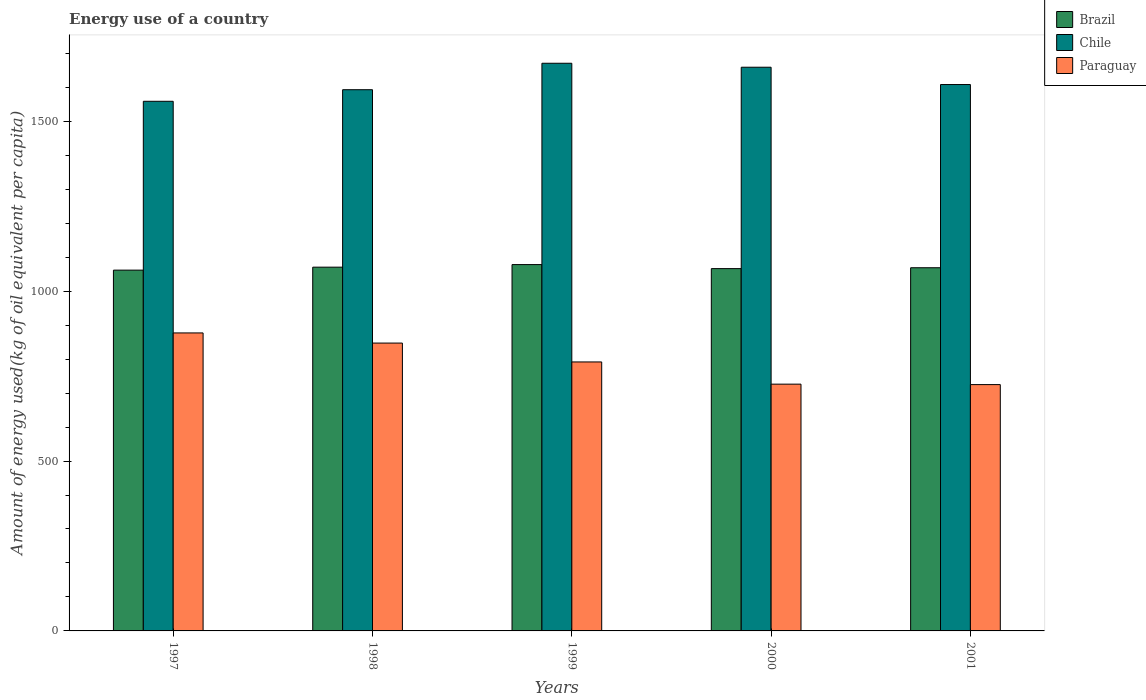How many different coloured bars are there?
Make the answer very short. 3. Are the number of bars per tick equal to the number of legend labels?
Keep it short and to the point. Yes. How many bars are there on the 1st tick from the left?
Make the answer very short. 3. How many bars are there on the 4th tick from the right?
Ensure brevity in your answer.  3. What is the label of the 5th group of bars from the left?
Make the answer very short. 2001. What is the amount of energy used in in Chile in 1999?
Keep it short and to the point. 1670.7. Across all years, what is the maximum amount of energy used in in Brazil?
Ensure brevity in your answer.  1078.18. Across all years, what is the minimum amount of energy used in in Paraguay?
Your answer should be very brief. 724.96. In which year was the amount of energy used in in Paraguay minimum?
Ensure brevity in your answer.  2001. What is the total amount of energy used in in Paraguay in the graph?
Make the answer very short. 3967.11. What is the difference between the amount of energy used in in Brazil in 1998 and that in 2001?
Your answer should be compact. 1.69. What is the difference between the amount of energy used in in Paraguay in 2000 and the amount of energy used in in Chile in 1998?
Keep it short and to the point. -866.56. What is the average amount of energy used in in Paraguay per year?
Ensure brevity in your answer.  793.42. In the year 2001, what is the difference between the amount of energy used in in Paraguay and amount of energy used in in Brazil?
Provide a succinct answer. -343.93. In how many years, is the amount of energy used in in Brazil greater than 1200 kg?
Provide a succinct answer. 0. What is the ratio of the amount of energy used in in Brazil in 1997 to that in 2001?
Give a very brief answer. 0.99. Is the difference between the amount of energy used in in Paraguay in 1998 and 1999 greater than the difference between the amount of energy used in in Brazil in 1998 and 1999?
Give a very brief answer. Yes. What is the difference between the highest and the second highest amount of energy used in in Brazil?
Your answer should be compact. 7.59. What is the difference between the highest and the lowest amount of energy used in in Brazil?
Offer a very short reply. 16.35. What does the 3rd bar from the left in 1998 represents?
Provide a short and direct response. Paraguay. How many bars are there?
Ensure brevity in your answer.  15. Are the values on the major ticks of Y-axis written in scientific E-notation?
Provide a short and direct response. No. Does the graph contain any zero values?
Offer a very short reply. No. Does the graph contain grids?
Make the answer very short. No. Where does the legend appear in the graph?
Give a very brief answer. Top right. What is the title of the graph?
Provide a succinct answer. Energy use of a country. What is the label or title of the X-axis?
Ensure brevity in your answer.  Years. What is the label or title of the Y-axis?
Your response must be concise. Amount of energy used(kg of oil equivalent per capita). What is the Amount of energy used(kg of oil equivalent per capita) in Brazil in 1997?
Your response must be concise. 1061.84. What is the Amount of energy used(kg of oil equivalent per capita) in Chile in 1997?
Your answer should be very brief. 1558.79. What is the Amount of energy used(kg of oil equivalent per capita) of Paraguay in 1997?
Your response must be concise. 877.04. What is the Amount of energy used(kg of oil equivalent per capita) of Brazil in 1998?
Your response must be concise. 1070.59. What is the Amount of energy used(kg of oil equivalent per capita) in Chile in 1998?
Give a very brief answer. 1592.83. What is the Amount of energy used(kg of oil equivalent per capita) of Paraguay in 1998?
Keep it short and to the point. 847.18. What is the Amount of energy used(kg of oil equivalent per capita) of Brazil in 1999?
Make the answer very short. 1078.18. What is the Amount of energy used(kg of oil equivalent per capita) in Chile in 1999?
Offer a terse response. 1670.7. What is the Amount of energy used(kg of oil equivalent per capita) in Paraguay in 1999?
Your answer should be very brief. 791.65. What is the Amount of energy used(kg of oil equivalent per capita) of Brazil in 2000?
Keep it short and to the point. 1066.3. What is the Amount of energy used(kg of oil equivalent per capita) in Chile in 2000?
Provide a succinct answer. 1659.01. What is the Amount of energy used(kg of oil equivalent per capita) of Paraguay in 2000?
Your answer should be compact. 726.27. What is the Amount of energy used(kg of oil equivalent per capita) in Brazil in 2001?
Keep it short and to the point. 1068.9. What is the Amount of energy used(kg of oil equivalent per capita) of Chile in 2001?
Give a very brief answer. 1608.07. What is the Amount of energy used(kg of oil equivalent per capita) in Paraguay in 2001?
Your answer should be compact. 724.96. Across all years, what is the maximum Amount of energy used(kg of oil equivalent per capita) of Brazil?
Keep it short and to the point. 1078.18. Across all years, what is the maximum Amount of energy used(kg of oil equivalent per capita) in Chile?
Ensure brevity in your answer.  1670.7. Across all years, what is the maximum Amount of energy used(kg of oil equivalent per capita) of Paraguay?
Offer a very short reply. 877.04. Across all years, what is the minimum Amount of energy used(kg of oil equivalent per capita) of Brazil?
Offer a terse response. 1061.84. Across all years, what is the minimum Amount of energy used(kg of oil equivalent per capita) of Chile?
Ensure brevity in your answer.  1558.79. Across all years, what is the minimum Amount of energy used(kg of oil equivalent per capita) in Paraguay?
Give a very brief answer. 724.96. What is the total Amount of energy used(kg of oil equivalent per capita) of Brazil in the graph?
Provide a short and direct response. 5345.81. What is the total Amount of energy used(kg of oil equivalent per capita) of Chile in the graph?
Make the answer very short. 8089.39. What is the total Amount of energy used(kg of oil equivalent per capita) in Paraguay in the graph?
Offer a terse response. 3967.11. What is the difference between the Amount of energy used(kg of oil equivalent per capita) in Brazil in 1997 and that in 1998?
Give a very brief answer. -8.75. What is the difference between the Amount of energy used(kg of oil equivalent per capita) of Chile in 1997 and that in 1998?
Provide a succinct answer. -34.05. What is the difference between the Amount of energy used(kg of oil equivalent per capita) of Paraguay in 1997 and that in 1998?
Keep it short and to the point. 29.86. What is the difference between the Amount of energy used(kg of oil equivalent per capita) of Brazil in 1997 and that in 1999?
Offer a terse response. -16.35. What is the difference between the Amount of energy used(kg of oil equivalent per capita) in Chile in 1997 and that in 1999?
Your response must be concise. -111.91. What is the difference between the Amount of energy used(kg of oil equivalent per capita) of Paraguay in 1997 and that in 1999?
Offer a terse response. 85.4. What is the difference between the Amount of energy used(kg of oil equivalent per capita) of Brazil in 1997 and that in 2000?
Offer a terse response. -4.47. What is the difference between the Amount of energy used(kg of oil equivalent per capita) of Chile in 1997 and that in 2000?
Give a very brief answer. -100.22. What is the difference between the Amount of energy used(kg of oil equivalent per capita) of Paraguay in 1997 and that in 2000?
Offer a very short reply. 150.77. What is the difference between the Amount of energy used(kg of oil equivalent per capita) of Brazil in 1997 and that in 2001?
Give a very brief answer. -7.06. What is the difference between the Amount of energy used(kg of oil equivalent per capita) of Chile in 1997 and that in 2001?
Keep it short and to the point. -49.28. What is the difference between the Amount of energy used(kg of oil equivalent per capita) in Paraguay in 1997 and that in 2001?
Ensure brevity in your answer.  152.08. What is the difference between the Amount of energy used(kg of oil equivalent per capita) in Brazil in 1998 and that in 1999?
Keep it short and to the point. -7.59. What is the difference between the Amount of energy used(kg of oil equivalent per capita) of Chile in 1998 and that in 1999?
Your answer should be very brief. -77.87. What is the difference between the Amount of energy used(kg of oil equivalent per capita) in Paraguay in 1998 and that in 1999?
Your answer should be compact. 55.54. What is the difference between the Amount of energy used(kg of oil equivalent per capita) of Brazil in 1998 and that in 2000?
Your answer should be compact. 4.29. What is the difference between the Amount of energy used(kg of oil equivalent per capita) in Chile in 1998 and that in 2000?
Make the answer very short. -66.17. What is the difference between the Amount of energy used(kg of oil equivalent per capita) in Paraguay in 1998 and that in 2000?
Your response must be concise. 120.91. What is the difference between the Amount of energy used(kg of oil equivalent per capita) of Brazil in 1998 and that in 2001?
Your answer should be compact. 1.69. What is the difference between the Amount of energy used(kg of oil equivalent per capita) of Chile in 1998 and that in 2001?
Your answer should be compact. -15.24. What is the difference between the Amount of energy used(kg of oil equivalent per capita) of Paraguay in 1998 and that in 2001?
Provide a short and direct response. 122.22. What is the difference between the Amount of energy used(kg of oil equivalent per capita) in Brazil in 1999 and that in 2000?
Your response must be concise. 11.88. What is the difference between the Amount of energy used(kg of oil equivalent per capita) of Chile in 1999 and that in 2000?
Give a very brief answer. 11.69. What is the difference between the Amount of energy used(kg of oil equivalent per capita) of Paraguay in 1999 and that in 2000?
Give a very brief answer. 65.38. What is the difference between the Amount of energy used(kg of oil equivalent per capita) of Brazil in 1999 and that in 2001?
Give a very brief answer. 9.29. What is the difference between the Amount of energy used(kg of oil equivalent per capita) in Chile in 1999 and that in 2001?
Ensure brevity in your answer.  62.63. What is the difference between the Amount of energy used(kg of oil equivalent per capita) of Paraguay in 1999 and that in 2001?
Offer a terse response. 66.68. What is the difference between the Amount of energy used(kg of oil equivalent per capita) in Brazil in 2000 and that in 2001?
Provide a short and direct response. -2.59. What is the difference between the Amount of energy used(kg of oil equivalent per capita) in Chile in 2000 and that in 2001?
Offer a terse response. 50.94. What is the difference between the Amount of energy used(kg of oil equivalent per capita) in Paraguay in 2000 and that in 2001?
Offer a very short reply. 1.31. What is the difference between the Amount of energy used(kg of oil equivalent per capita) in Brazil in 1997 and the Amount of energy used(kg of oil equivalent per capita) in Chile in 1998?
Provide a succinct answer. -531. What is the difference between the Amount of energy used(kg of oil equivalent per capita) of Brazil in 1997 and the Amount of energy used(kg of oil equivalent per capita) of Paraguay in 1998?
Make the answer very short. 214.65. What is the difference between the Amount of energy used(kg of oil equivalent per capita) of Chile in 1997 and the Amount of energy used(kg of oil equivalent per capita) of Paraguay in 1998?
Offer a terse response. 711.6. What is the difference between the Amount of energy used(kg of oil equivalent per capita) of Brazil in 1997 and the Amount of energy used(kg of oil equivalent per capita) of Chile in 1999?
Your answer should be compact. -608.86. What is the difference between the Amount of energy used(kg of oil equivalent per capita) of Brazil in 1997 and the Amount of energy used(kg of oil equivalent per capita) of Paraguay in 1999?
Provide a short and direct response. 270.19. What is the difference between the Amount of energy used(kg of oil equivalent per capita) of Chile in 1997 and the Amount of energy used(kg of oil equivalent per capita) of Paraguay in 1999?
Keep it short and to the point. 767.14. What is the difference between the Amount of energy used(kg of oil equivalent per capita) in Brazil in 1997 and the Amount of energy used(kg of oil equivalent per capita) in Chile in 2000?
Your answer should be compact. -597.17. What is the difference between the Amount of energy used(kg of oil equivalent per capita) in Brazil in 1997 and the Amount of energy used(kg of oil equivalent per capita) in Paraguay in 2000?
Ensure brevity in your answer.  335.57. What is the difference between the Amount of energy used(kg of oil equivalent per capita) in Chile in 1997 and the Amount of energy used(kg of oil equivalent per capita) in Paraguay in 2000?
Provide a short and direct response. 832.52. What is the difference between the Amount of energy used(kg of oil equivalent per capita) of Brazil in 1997 and the Amount of energy used(kg of oil equivalent per capita) of Chile in 2001?
Keep it short and to the point. -546.23. What is the difference between the Amount of energy used(kg of oil equivalent per capita) of Brazil in 1997 and the Amount of energy used(kg of oil equivalent per capita) of Paraguay in 2001?
Offer a very short reply. 336.87. What is the difference between the Amount of energy used(kg of oil equivalent per capita) of Chile in 1997 and the Amount of energy used(kg of oil equivalent per capita) of Paraguay in 2001?
Give a very brief answer. 833.82. What is the difference between the Amount of energy used(kg of oil equivalent per capita) in Brazil in 1998 and the Amount of energy used(kg of oil equivalent per capita) in Chile in 1999?
Keep it short and to the point. -600.11. What is the difference between the Amount of energy used(kg of oil equivalent per capita) in Brazil in 1998 and the Amount of energy used(kg of oil equivalent per capita) in Paraguay in 1999?
Provide a short and direct response. 278.94. What is the difference between the Amount of energy used(kg of oil equivalent per capita) in Chile in 1998 and the Amount of energy used(kg of oil equivalent per capita) in Paraguay in 1999?
Give a very brief answer. 801.19. What is the difference between the Amount of energy used(kg of oil equivalent per capita) in Brazil in 1998 and the Amount of energy used(kg of oil equivalent per capita) in Chile in 2000?
Offer a terse response. -588.42. What is the difference between the Amount of energy used(kg of oil equivalent per capita) in Brazil in 1998 and the Amount of energy used(kg of oil equivalent per capita) in Paraguay in 2000?
Offer a terse response. 344.32. What is the difference between the Amount of energy used(kg of oil equivalent per capita) in Chile in 1998 and the Amount of energy used(kg of oil equivalent per capita) in Paraguay in 2000?
Make the answer very short. 866.56. What is the difference between the Amount of energy used(kg of oil equivalent per capita) in Brazil in 1998 and the Amount of energy used(kg of oil equivalent per capita) in Chile in 2001?
Your response must be concise. -537.48. What is the difference between the Amount of energy used(kg of oil equivalent per capita) of Brazil in 1998 and the Amount of energy used(kg of oil equivalent per capita) of Paraguay in 2001?
Offer a very short reply. 345.63. What is the difference between the Amount of energy used(kg of oil equivalent per capita) of Chile in 1998 and the Amount of energy used(kg of oil equivalent per capita) of Paraguay in 2001?
Offer a very short reply. 867.87. What is the difference between the Amount of energy used(kg of oil equivalent per capita) of Brazil in 1999 and the Amount of energy used(kg of oil equivalent per capita) of Chile in 2000?
Your response must be concise. -580.82. What is the difference between the Amount of energy used(kg of oil equivalent per capita) of Brazil in 1999 and the Amount of energy used(kg of oil equivalent per capita) of Paraguay in 2000?
Ensure brevity in your answer.  351.91. What is the difference between the Amount of energy used(kg of oil equivalent per capita) in Chile in 1999 and the Amount of energy used(kg of oil equivalent per capita) in Paraguay in 2000?
Your answer should be compact. 944.43. What is the difference between the Amount of energy used(kg of oil equivalent per capita) in Brazil in 1999 and the Amount of energy used(kg of oil equivalent per capita) in Chile in 2001?
Ensure brevity in your answer.  -529.89. What is the difference between the Amount of energy used(kg of oil equivalent per capita) in Brazil in 1999 and the Amount of energy used(kg of oil equivalent per capita) in Paraguay in 2001?
Ensure brevity in your answer.  353.22. What is the difference between the Amount of energy used(kg of oil equivalent per capita) of Chile in 1999 and the Amount of energy used(kg of oil equivalent per capita) of Paraguay in 2001?
Your response must be concise. 945.74. What is the difference between the Amount of energy used(kg of oil equivalent per capita) of Brazil in 2000 and the Amount of energy used(kg of oil equivalent per capita) of Chile in 2001?
Keep it short and to the point. -541.77. What is the difference between the Amount of energy used(kg of oil equivalent per capita) in Brazil in 2000 and the Amount of energy used(kg of oil equivalent per capita) in Paraguay in 2001?
Keep it short and to the point. 341.34. What is the difference between the Amount of energy used(kg of oil equivalent per capita) of Chile in 2000 and the Amount of energy used(kg of oil equivalent per capita) of Paraguay in 2001?
Provide a succinct answer. 934.04. What is the average Amount of energy used(kg of oil equivalent per capita) in Brazil per year?
Give a very brief answer. 1069.16. What is the average Amount of energy used(kg of oil equivalent per capita) in Chile per year?
Your answer should be very brief. 1617.88. What is the average Amount of energy used(kg of oil equivalent per capita) of Paraguay per year?
Offer a terse response. 793.42. In the year 1997, what is the difference between the Amount of energy used(kg of oil equivalent per capita) of Brazil and Amount of energy used(kg of oil equivalent per capita) of Chile?
Offer a terse response. -496.95. In the year 1997, what is the difference between the Amount of energy used(kg of oil equivalent per capita) in Brazil and Amount of energy used(kg of oil equivalent per capita) in Paraguay?
Ensure brevity in your answer.  184.79. In the year 1997, what is the difference between the Amount of energy used(kg of oil equivalent per capita) of Chile and Amount of energy used(kg of oil equivalent per capita) of Paraguay?
Your response must be concise. 681.74. In the year 1998, what is the difference between the Amount of energy used(kg of oil equivalent per capita) in Brazil and Amount of energy used(kg of oil equivalent per capita) in Chile?
Your answer should be compact. -522.24. In the year 1998, what is the difference between the Amount of energy used(kg of oil equivalent per capita) of Brazil and Amount of energy used(kg of oil equivalent per capita) of Paraguay?
Make the answer very short. 223.4. In the year 1998, what is the difference between the Amount of energy used(kg of oil equivalent per capita) of Chile and Amount of energy used(kg of oil equivalent per capita) of Paraguay?
Keep it short and to the point. 745.65. In the year 1999, what is the difference between the Amount of energy used(kg of oil equivalent per capita) in Brazil and Amount of energy used(kg of oil equivalent per capita) in Chile?
Your response must be concise. -592.52. In the year 1999, what is the difference between the Amount of energy used(kg of oil equivalent per capita) of Brazil and Amount of energy used(kg of oil equivalent per capita) of Paraguay?
Provide a short and direct response. 286.54. In the year 1999, what is the difference between the Amount of energy used(kg of oil equivalent per capita) in Chile and Amount of energy used(kg of oil equivalent per capita) in Paraguay?
Provide a short and direct response. 879.05. In the year 2000, what is the difference between the Amount of energy used(kg of oil equivalent per capita) of Brazil and Amount of energy used(kg of oil equivalent per capita) of Chile?
Your answer should be compact. -592.7. In the year 2000, what is the difference between the Amount of energy used(kg of oil equivalent per capita) of Brazil and Amount of energy used(kg of oil equivalent per capita) of Paraguay?
Provide a short and direct response. 340.03. In the year 2000, what is the difference between the Amount of energy used(kg of oil equivalent per capita) in Chile and Amount of energy used(kg of oil equivalent per capita) in Paraguay?
Make the answer very short. 932.74. In the year 2001, what is the difference between the Amount of energy used(kg of oil equivalent per capita) of Brazil and Amount of energy used(kg of oil equivalent per capita) of Chile?
Your answer should be compact. -539.17. In the year 2001, what is the difference between the Amount of energy used(kg of oil equivalent per capita) of Brazil and Amount of energy used(kg of oil equivalent per capita) of Paraguay?
Offer a terse response. 343.93. In the year 2001, what is the difference between the Amount of energy used(kg of oil equivalent per capita) of Chile and Amount of energy used(kg of oil equivalent per capita) of Paraguay?
Keep it short and to the point. 883.11. What is the ratio of the Amount of energy used(kg of oil equivalent per capita) in Chile in 1997 to that in 1998?
Your answer should be compact. 0.98. What is the ratio of the Amount of energy used(kg of oil equivalent per capita) of Paraguay in 1997 to that in 1998?
Give a very brief answer. 1.04. What is the ratio of the Amount of energy used(kg of oil equivalent per capita) in Chile in 1997 to that in 1999?
Provide a short and direct response. 0.93. What is the ratio of the Amount of energy used(kg of oil equivalent per capita) in Paraguay in 1997 to that in 1999?
Offer a very short reply. 1.11. What is the ratio of the Amount of energy used(kg of oil equivalent per capita) of Chile in 1997 to that in 2000?
Give a very brief answer. 0.94. What is the ratio of the Amount of energy used(kg of oil equivalent per capita) of Paraguay in 1997 to that in 2000?
Offer a terse response. 1.21. What is the ratio of the Amount of energy used(kg of oil equivalent per capita) in Brazil in 1997 to that in 2001?
Your answer should be compact. 0.99. What is the ratio of the Amount of energy used(kg of oil equivalent per capita) in Chile in 1997 to that in 2001?
Offer a terse response. 0.97. What is the ratio of the Amount of energy used(kg of oil equivalent per capita) in Paraguay in 1997 to that in 2001?
Your answer should be very brief. 1.21. What is the ratio of the Amount of energy used(kg of oil equivalent per capita) of Brazil in 1998 to that in 1999?
Your answer should be very brief. 0.99. What is the ratio of the Amount of energy used(kg of oil equivalent per capita) in Chile in 1998 to that in 1999?
Your response must be concise. 0.95. What is the ratio of the Amount of energy used(kg of oil equivalent per capita) of Paraguay in 1998 to that in 1999?
Keep it short and to the point. 1.07. What is the ratio of the Amount of energy used(kg of oil equivalent per capita) in Chile in 1998 to that in 2000?
Your response must be concise. 0.96. What is the ratio of the Amount of energy used(kg of oil equivalent per capita) in Paraguay in 1998 to that in 2000?
Offer a terse response. 1.17. What is the ratio of the Amount of energy used(kg of oil equivalent per capita) of Paraguay in 1998 to that in 2001?
Offer a very short reply. 1.17. What is the ratio of the Amount of energy used(kg of oil equivalent per capita) in Brazil in 1999 to that in 2000?
Keep it short and to the point. 1.01. What is the ratio of the Amount of energy used(kg of oil equivalent per capita) of Chile in 1999 to that in 2000?
Make the answer very short. 1.01. What is the ratio of the Amount of energy used(kg of oil equivalent per capita) of Paraguay in 1999 to that in 2000?
Provide a succinct answer. 1.09. What is the ratio of the Amount of energy used(kg of oil equivalent per capita) of Brazil in 1999 to that in 2001?
Ensure brevity in your answer.  1.01. What is the ratio of the Amount of energy used(kg of oil equivalent per capita) in Chile in 1999 to that in 2001?
Ensure brevity in your answer.  1.04. What is the ratio of the Amount of energy used(kg of oil equivalent per capita) in Paraguay in 1999 to that in 2001?
Your response must be concise. 1.09. What is the ratio of the Amount of energy used(kg of oil equivalent per capita) of Chile in 2000 to that in 2001?
Keep it short and to the point. 1.03. What is the ratio of the Amount of energy used(kg of oil equivalent per capita) in Paraguay in 2000 to that in 2001?
Your answer should be very brief. 1. What is the difference between the highest and the second highest Amount of energy used(kg of oil equivalent per capita) in Brazil?
Make the answer very short. 7.59. What is the difference between the highest and the second highest Amount of energy used(kg of oil equivalent per capita) in Chile?
Keep it short and to the point. 11.69. What is the difference between the highest and the second highest Amount of energy used(kg of oil equivalent per capita) in Paraguay?
Your answer should be compact. 29.86. What is the difference between the highest and the lowest Amount of energy used(kg of oil equivalent per capita) of Brazil?
Provide a short and direct response. 16.35. What is the difference between the highest and the lowest Amount of energy used(kg of oil equivalent per capita) in Chile?
Offer a terse response. 111.91. What is the difference between the highest and the lowest Amount of energy used(kg of oil equivalent per capita) in Paraguay?
Keep it short and to the point. 152.08. 